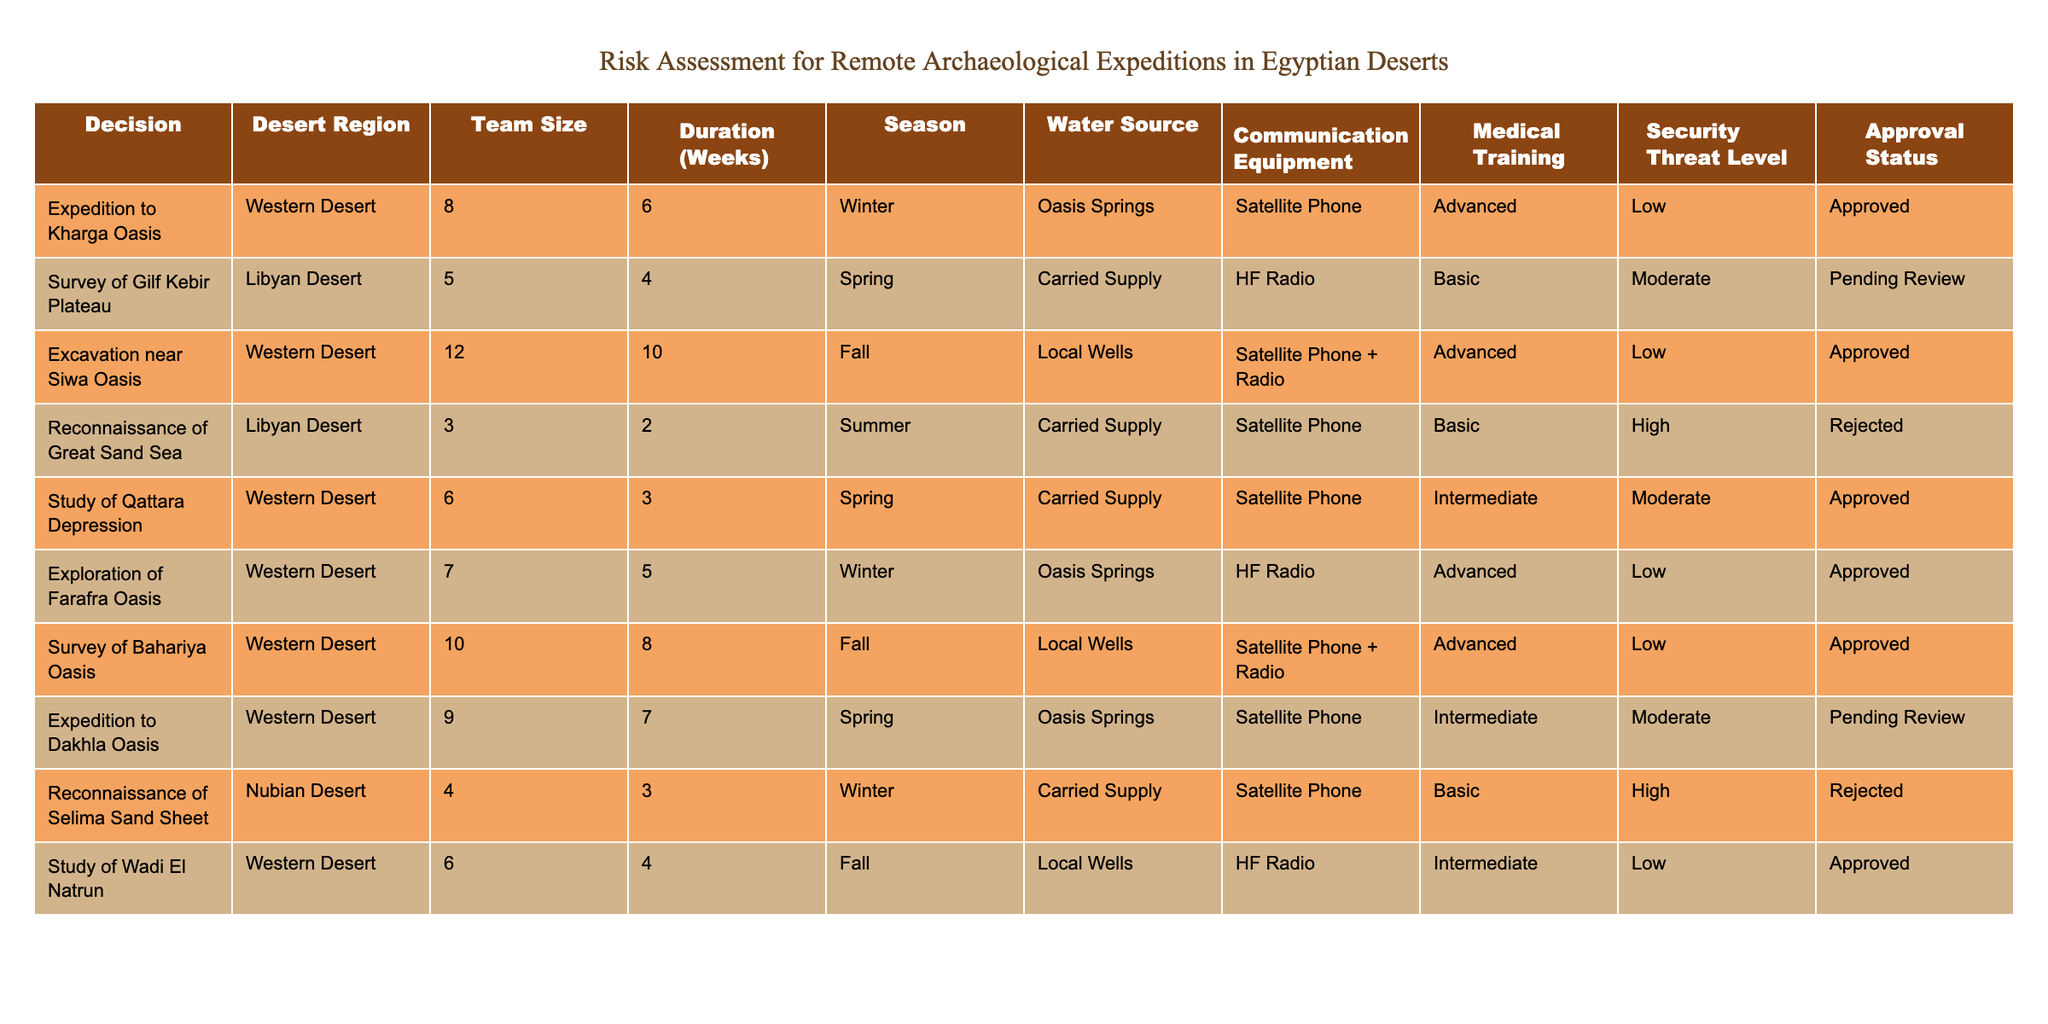What is the team size for the excavation near Siwa Oasis? The table explicitly states the information for this expedition under the "Team Size" column, which indicates that the team size is 12 members.
Answer: 12 How many expeditions were approved? By counting the rows with "Approved" in the approval status column, we find that there are 6 such expeditions.
Answer: 6 What is the average duration of all the expeditions planned? First, we list all the durations: 6, 4, 10, 2, 3, 5, 8, 7, 3, and 4 weeks. Adding them up gives 48 weeks. There are 10 expeditions, so the average duration is 48/10 = 4.8 weeks.
Answer: 4.8 Are there any expeditions that have a high-security threat level and were approved? Looking at the security threat level and approval status together, we see that all expeditions with a high-security threat level are either rejected or pending review, thus no approved expeditions fit this description.
Answer: No What is the total number of team members involved in expeditions during the winter season? For winter expeditions, we observe the corresponding team sizes: 8 for Kharga Oasis, 7 for Farafra Oasis, and 4 for Selima Sand Sheet. The total team size is 8 + 7 + 4 = 19 members for winter expeditions.
Answer: 19 How does the communication equipment differ between approved and rejected expeditions? In the table, the approved expeditions primarily use satellite phones, while rejected expeditions use HF radio or lack clear communication devices, indicating that the rejected expeditions have less reliable equipment compared to the approved ones.
Answer: Approved use satellite phones, rejected use less reliable equipment What percentage of expeditions planned are set for the spring season? There are 10 expeditions total, and 3 of these (Gilf Kebir, Dakhla Oasis, and Qattara Depression) are scheduled for spring. To calculate the percentage: (3/10) * 100 = 30%.
Answer: 30% Are all expeditions that rely on local wells approved? By checking the approval status of expeditions that depend on local wells (Siwa Oasis, Bahariya Oasis, and Wadi El Natrun), we see that Siwa and Bahariya are approved, but Wadi El Natrun is approved too. Therefore, all expeditions relying on this water source are approved.
Answer: Yes What is the longest expedition planned in terms of duration, and where is it located? The longest duration in the table is 10 weeks, which corresponds to the excavation near Siwa Oasis, as observed in the "Duration (Weeks)" column.
Answer: Excavation near Siwa Oasis, 10 weeks 